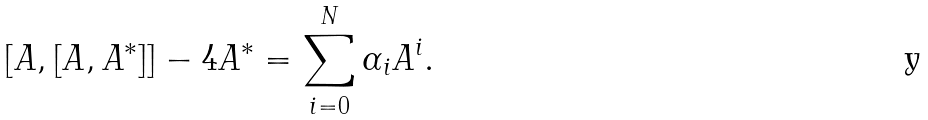<formula> <loc_0><loc_0><loc_500><loc_500>[ A , [ A , A ^ { * } ] ] - 4 A ^ { * } = \sum _ { i = 0 } ^ { N } \alpha _ { i } A ^ { i } .</formula> 